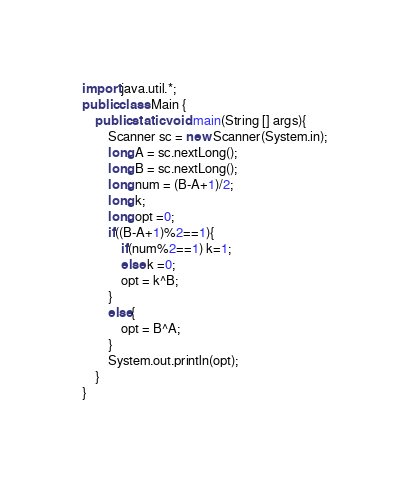Convert code to text. <code><loc_0><loc_0><loc_500><loc_500><_Java_>import java.util.*;
public class Main {
    public static void main(String [] args){
        Scanner sc = new Scanner(System.in);
        long A = sc.nextLong();
        long B = sc.nextLong();
        long num = (B-A+1)/2;
        long k;
        long opt =0;
        if((B-A+1)%2==1){
            if(num%2==1) k=1;
            else k =0;
            opt = k^B;
        }
        else{
            opt = B^A;
        }
        System.out.println(opt);
    }
}</code> 